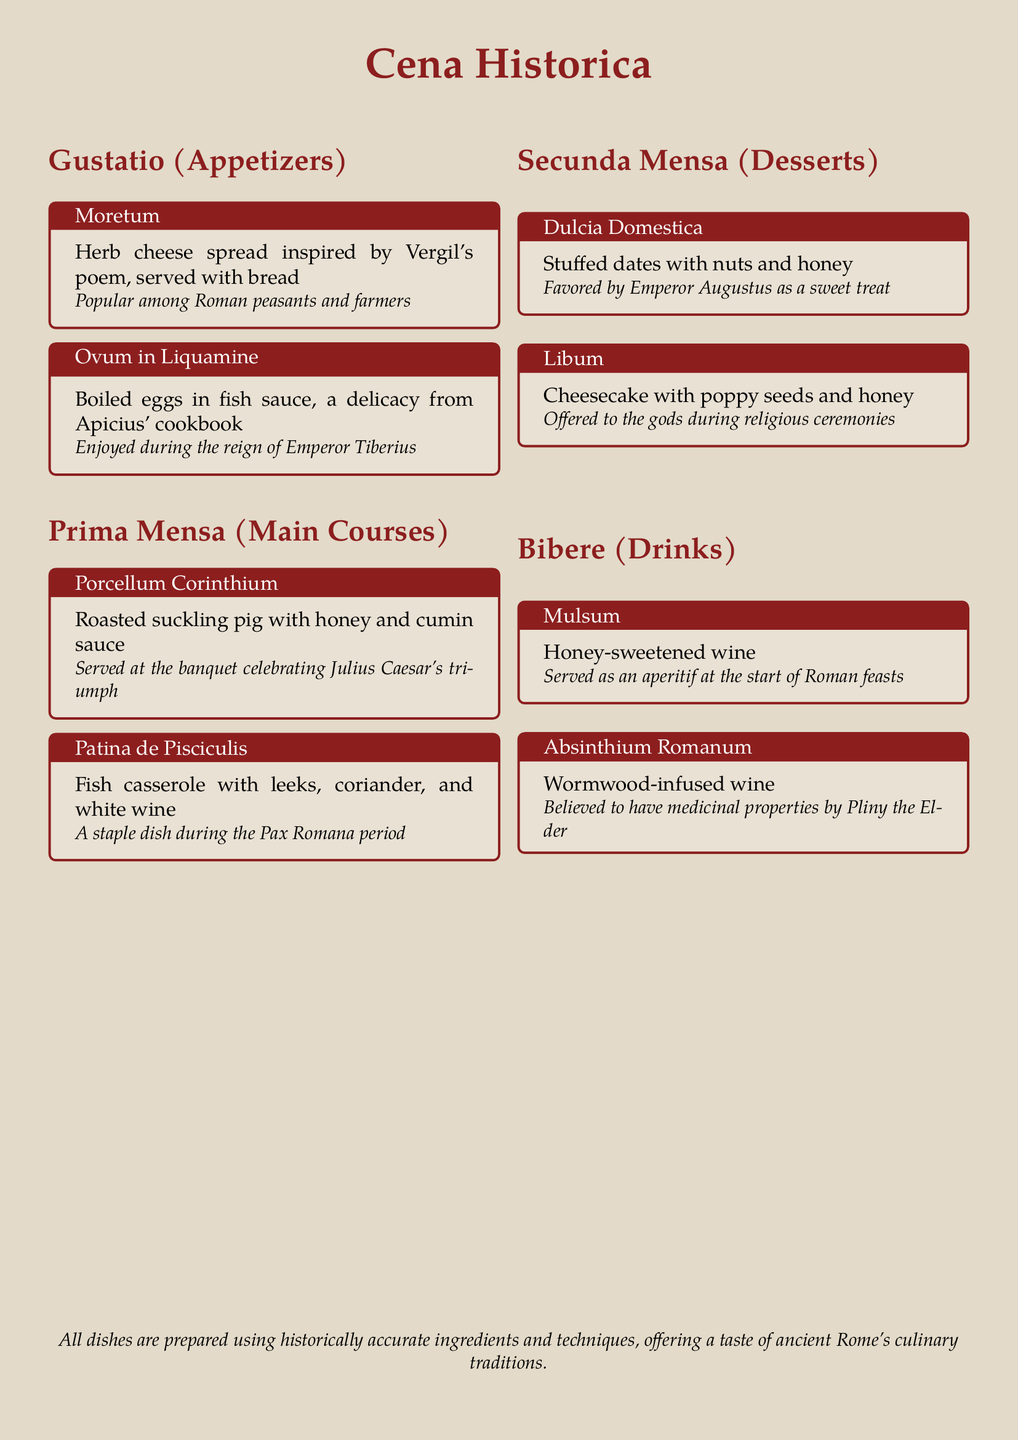What is the name of the first appetizer? The first appetizer listed in the document is Moretum, which is an herb cheese spread.
Answer: Moretum Which dish was served at Julius Caesar's triumph? The dish mentioned is Porcellum Corinthium, which is a roasted suckling pig with honey and cumin sauce, served at the banquet celebrating Julius Caesar's triumph.
Answer: Porcellum Corinthium What type of cheese is Libum based on? Libum is a cheesecake, as indicated in the dessert section of the menu.
Answer: Cheesecake Who favored Dulcia Domestica? The dessert Dulcia Domestica, stuffed dates with nuts and honey, was favored by Emperor Augustus.
Answer: Emperor Augustus What beverage was served as an aperitif? The beverage served as an aperitif at the start of Roman feasts is Mulsum, which is honey-sweetened wine.
Answer: Mulsum What culinary technique is emphasized in the menu descriptions? The menu emphasizes the use of historically accurate ingredients and techniques.
Answer: Historically accurate ingredients and techniques What is the significance of Absinthium Romanum? Absinthium Romanum, wormwood-infused wine, is noted for its believed medicinal properties.
Answer: Medicinal properties Which dessert was offered to the gods? The dessert offered to the gods during religious ceremonies is Libum.
Answer: Libum What historical period is Patina de Pisciculis associated with? Patina de Pisciculis is associated with the Pax Romana period as a staple dish.
Answer: Pax Romana 